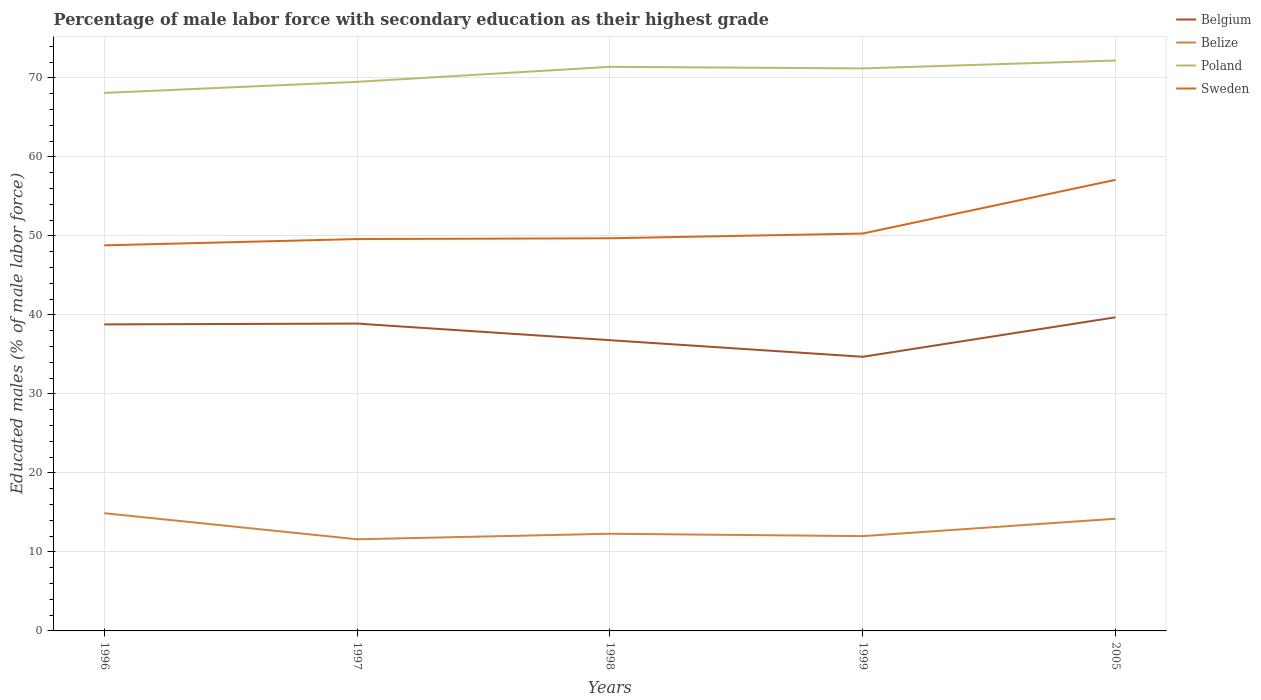How many different coloured lines are there?
Make the answer very short. 4. Across all years, what is the maximum percentage of male labor force with secondary education in Poland?
Provide a succinct answer. 68.1. What is the total percentage of male labor force with secondary education in Belize in the graph?
Your response must be concise. -0.4. What is the difference between the highest and the second highest percentage of male labor force with secondary education in Belize?
Offer a terse response. 3.3. How many lines are there?
Make the answer very short. 4. Does the graph contain any zero values?
Give a very brief answer. No. Does the graph contain grids?
Provide a succinct answer. Yes. Where does the legend appear in the graph?
Provide a succinct answer. Top right. How many legend labels are there?
Provide a short and direct response. 4. How are the legend labels stacked?
Your answer should be compact. Vertical. What is the title of the graph?
Offer a terse response. Percentage of male labor force with secondary education as their highest grade. What is the label or title of the X-axis?
Give a very brief answer. Years. What is the label or title of the Y-axis?
Ensure brevity in your answer.  Educated males (% of male labor force). What is the Educated males (% of male labor force) in Belgium in 1996?
Give a very brief answer. 38.8. What is the Educated males (% of male labor force) of Belize in 1996?
Offer a very short reply. 14.9. What is the Educated males (% of male labor force) in Poland in 1996?
Give a very brief answer. 68.1. What is the Educated males (% of male labor force) in Sweden in 1996?
Offer a very short reply. 48.8. What is the Educated males (% of male labor force) of Belgium in 1997?
Give a very brief answer. 38.9. What is the Educated males (% of male labor force) in Belize in 1997?
Ensure brevity in your answer.  11.6. What is the Educated males (% of male labor force) in Poland in 1997?
Your response must be concise. 69.5. What is the Educated males (% of male labor force) of Sweden in 1997?
Your response must be concise. 49.6. What is the Educated males (% of male labor force) in Belgium in 1998?
Keep it short and to the point. 36.8. What is the Educated males (% of male labor force) of Belize in 1998?
Give a very brief answer. 12.3. What is the Educated males (% of male labor force) in Poland in 1998?
Provide a succinct answer. 71.4. What is the Educated males (% of male labor force) of Sweden in 1998?
Offer a very short reply. 49.7. What is the Educated males (% of male labor force) of Belgium in 1999?
Your answer should be very brief. 34.7. What is the Educated males (% of male labor force) in Poland in 1999?
Your answer should be compact. 71.2. What is the Educated males (% of male labor force) of Sweden in 1999?
Make the answer very short. 50.3. What is the Educated males (% of male labor force) of Belgium in 2005?
Offer a very short reply. 39.7. What is the Educated males (% of male labor force) in Belize in 2005?
Provide a succinct answer. 14.2. What is the Educated males (% of male labor force) of Poland in 2005?
Give a very brief answer. 72.2. What is the Educated males (% of male labor force) of Sweden in 2005?
Offer a very short reply. 57.1. Across all years, what is the maximum Educated males (% of male labor force) of Belgium?
Make the answer very short. 39.7. Across all years, what is the maximum Educated males (% of male labor force) of Belize?
Provide a succinct answer. 14.9. Across all years, what is the maximum Educated males (% of male labor force) of Poland?
Offer a terse response. 72.2. Across all years, what is the maximum Educated males (% of male labor force) in Sweden?
Provide a succinct answer. 57.1. Across all years, what is the minimum Educated males (% of male labor force) in Belgium?
Keep it short and to the point. 34.7. Across all years, what is the minimum Educated males (% of male labor force) in Belize?
Provide a succinct answer. 11.6. Across all years, what is the minimum Educated males (% of male labor force) of Poland?
Your response must be concise. 68.1. Across all years, what is the minimum Educated males (% of male labor force) of Sweden?
Ensure brevity in your answer.  48.8. What is the total Educated males (% of male labor force) in Belgium in the graph?
Your response must be concise. 188.9. What is the total Educated males (% of male labor force) in Belize in the graph?
Ensure brevity in your answer.  65. What is the total Educated males (% of male labor force) of Poland in the graph?
Your answer should be compact. 352.4. What is the total Educated males (% of male labor force) in Sweden in the graph?
Offer a terse response. 255.5. What is the difference between the Educated males (% of male labor force) in Belize in 1996 and that in 1997?
Provide a succinct answer. 3.3. What is the difference between the Educated males (% of male labor force) of Poland in 1996 and that in 1997?
Make the answer very short. -1.4. What is the difference between the Educated males (% of male labor force) in Sweden in 1996 and that in 1997?
Keep it short and to the point. -0.8. What is the difference between the Educated males (% of male labor force) in Belize in 1996 and that in 1998?
Keep it short and to the point. 2.6. What is the difference between the Educated males (% of male labor force) of Poland in 1996 and that in 1998?
Provide a short and direct response. -3.3. What is the difference between the Educated males (% of male labor force) in Sweden in 1996 and that in 1998?
Your answer should be compact. -0.9. What is the difference between the Educated males (% of male labor force) of Sweden in 1996 and that in 1999?
Your answer should be very brief. -1.5. What is the difference between the Educated males (% of male labor force) in Belgium in 1996 and that in 2005?
Your answer should be compact. -0.9. What is the difference between the Educated males (% of male labor force) of Poland in 1996 and that in 2005?
Your answer should be compact. -4.1. What is the difference between the Educated males (% of male labor force) of Belgium in 1997 and that in 1998?
Provide a short and direct response. 2.1. What is the difference between the Educated males (% of male labor force) of Poland in 1997 and that in 1998?
Keep it short and to the point. -1.9. What is the difference between the Educated males (% of male labor force) of Poland in 1997 and that in 1999?
Your response must be concise. -1.7. What is the difference between the Educated males (% of male labor force) of Belize in 1997 and that in 2005?
Provide a succinct answer. -2.6. What is the difference between the Educated males (% of male labor force) in Sweden in 1997 and that in 2005?
Your answer should be very brief. -7.5. What is the difference between the Educated males (% of male labor force) of Belize in 1998 and that in 1999?
Your answer should be very brief. 0.3. What is the difference between the Educated males (% of male labor force) of Poland in 1998 and that in 1999?
Ensure brevity in your answer.  0.2. What is the difference between the Educated males (% of male labor force) in Sweden in 1998 and that in 1999?
Your answer should be compact. -0.6. What is the difference between the Educated males (% of male labor force) of Belgium in 1998 and that in 2005?
Provide a succinct answer. -2.9. What is the difference between the Educated males (% of male labor force) in Belize in 1998 and that in 2005?
Offer a very short reply. -1.9. What is the difference between the Educated males (% of male labor force) of Poland in 1998 and that in 2005?
Your response must be concise. -0.8. What is the difference between the Educated males (% of male labor force) in Sweden in 1998 and that in 2005?
Provide a short and direct response. -7.4. What is the difference between the Educated males (% of male labor force) of Belgium in 1999 and that in 2005?
Your answer should be compact. -5. What is the difference between the Educated males (% of male labor force) in Sweden in 1999 and that in 2005?
Provide a short and direct response. -6.8. What is the difference between the Educated males (% of male labor force) in Belgium in 1996 and the Educated males (% of male labor force) in Belize in 1997?
Give a very brief answer. 27.2. What is the difference between the Educated males (% of male labor force) in Belgium in 1996 and the Educated males (% of male labor force) in Poland in 1997?
Provide a short and direct response. -30.7. What is the difference between the Educated males (% of male labor force) of Belgium in 1996 and the Educated males (% of male labor force) of Sweden in 1997?
Provide a succinct answer. -10.8. What is the difference between the Educated males (% of male labor force) in Belize in 1996 and the Educated males (% of male labor force) in Poland in 1997?
Offer a terse response. -54.6. What is the difference between the Educated males (% of male labor force) in Belize in 1996 and the Educated males (% of male labor force) in Sweden in 1997?
Provide a succinct answer. -34.7. What is the difference between the Educated males (% of male labor force) in Poland in 1996 and the Educated males (% of male labor force) in Sweden in 1997?
Ensure brevity in your answer.  18.5. What is the difference between the Educated males (% of male labor force) of Belgium in 1996 and the Educated males (% of male labor force) of Poland in 1998?
Provide a succinct answer. -32.6. What is the difference between the Educated males (% of male labor force) in Belgium in 1996 and the Educated males (% of male labor force) in Sweden in 1998?
Ensure brevity in your answer.  -10.9. What is the difference between the Educated males (% of male labor force) of Belize in 1996 and the Educated males (% of male labor force) of Poland in 1998?
Your answer should be very brief. -56.5. What is the difference between the Educated males (% of male labor force) in Belize in 1996 and the Educated males (% of male labor force) in Sweden in 1998?
Keep it short and to the point. -34.8. What is the difference between the Educated males (% of male labor force) of Poland in 1996 and the Educated males (% of male labor force) of Sweden in 1998?
Keep it short and to the point. 18.4. What is the difference between the Educated males (% of male labor force) of Belgium in 1996 and the Educated males (% of male labor force) of Belize in 1999?
Give a very brief answer. 26.8. What is the difference between the Educated males (% of male labor force) in Belgium in 1996 and the Educated males (% of male labor force) in Poland in 1999?
Ensure brevity in your answer.  -32.4. What is the difference between the Educated males (% of male labor force) in Belize in 1996 and the Educated males (% of male labor force) in Poland in 1999?
Your answer should be compact. -56.3. What is the difference between the Educated males (% of male labor force) in Belize in 1996 and the Educated males (% of male labor force) in Sweden in 1999?
Your response must be concise. -35.4. What is the difference between the Educated males (% of male labor force) of Belgium in 1996 and the Educated males (% of male labor force) of Belize in 2005?
Keep it short and to the point. 24.6. What is the difference between the Educated males (% of male labor force) in Belgium in 1996 and the Educated males (% of male labor force) in Poland in 2005?
Provide a short and direct response. -33.4. What is the difference between the Educated males (% of male labor force) in Belgium in 1996 and the Educated males (% of male labor force) in Sweden in 2005?
Your answer should be compact. -18.3. What is the difference between the Educated males (% of male labor force) in Belize in 1996 and the Educated males (% of male labor force) in Poland in 2005?
Ensure brevity in your answer.  -57.3. What is the difference between the Educated males (% of male labor force) in Belize in 1996 and the Educated males (% of male labor force) in Sweden in 2005?
Offer a terse response. -42.2. What is the difference between the Educated males (% of male labor force) in Belgium in 1997 and the Educated males (% of male labor force) in Belize in 1998?
Offer a terse response. 26.6. What is the difference between the Educated males (% of male labor force) in Belgium in 1997 and the Educated males (% of male labor force) in Poland in 1998?
Your answer should be very brief. -32.5. What is the difference between the Educated males (% of male labor force) of Belgium in 1997 and the Educated males (% of male labor force) of Sweden in 1998?
Your answer should be very brief. -10.8. What is the difference between the Educated males (% of male labor force) in Belize in 1997 and the Educated males (% of male labor force) in Poland in 1998?
Your answer should be compact. -59.8. What is the difference between the Educated males (% of male labor force) of Belize in 1997 and the Educated males (% of male labor force) of Sweden in 1998?
Provide a succinct answer. -38.1. What is the difference between the Educated males (% of male labor force) of Poland in 1997 and the Educated males (% of male labor force) of Sweden in 1998?
Provide a succinct answer. 19.8. What is the difference between the Educated males (% of male labor force) in Belgium in 1997 and the Educated males (% of male labor force) in Belize in 1999?
Provide a succinct answer. 26.9. What is the difference between the Educated males (% of male labor force) in Belgium in 1997 and the Educated males (% of male labor force) in Poland in 1999?
Keep it short and to the point. -32.3. What is the difference between the Educated males (% of male labor force) of Belgium in 1997 and the Educated males (% of male labor force) of Sweden in 1999?
Your answer should be compact. -11.4. What is the difference between the Educated males (% of male labor force) of Belize in 1997 and the Educated males (% of male labor force) of Poland in 1999?
Give a very brief answer. -59.6. What is the difference between the Educated males (% of male labor force) in Belize in 1997 and the Educated males (% of male labor force) in Sweden in 1999?
Keep it short and to the point. -38.7. What is the difference between the Educated males (% of male labor force) in Poland in 1997 and the Educated males (% of male labor force) in Sweden in 1999?
Your response must be concise. 19.2. What is the difference between the Educated males (% of male labor force) in Belgium in 1997 and the Educated males (% of male labor force) in Belize in 2005?
Give a very brief answer. 24.7. What is the difference between the Educated males (% of male labor force) in Belgium in 1997 and the Educated males (% of male labor force) in Poland in 2005?
Offer a terse response. -33.3. What is the difference between the Educated males (% of male labor force) in Belgium in 1997 and the Educated males (% of male labor force) in Sweden in 2005?
Provide a succinct answer. -18.2. What is the difference between the Educated males (% of male labor force) in Belize in 1997 and the Educated males (% of male labor force) in Poland in 2005?
Provide a short and direct response. -60.6. What is the difference between the Educated males (% of male labor force) in Belize in 1997 and the Educated males (% of male labor force) in Sweden in 2005?
Give a very brief answer. -45.5. What is the difference between the Educated males (% of male labor force) in Belgium in 1998 and the Educated males (% of male labor force) in Belize in 1999?
Ensure brevity in your answer.  24.8. What is the difference between the Educated males (% of male labor force) in Belgium in 1998 and the Educated males (% of male labor force) in Poland in 1999?
Your answer should be very brief. -34.4. What is the difference between the Educated males (% of male labor force) in Belize in 1998 and the Educated males (% of male labor force) in Poland in 1999?
Your response must be concise. -58.9. What is the difference between the Educated males (% of male labor force) of Belize in 1998 and the Educated males (% of male labor force) of Sweden in 1999?
Offer a terse response. -38. What is the difference between the Educated males (% of male labor force) in Poland in 1998 and the Educated males (% of male labor force) in Sweden in 1999?
Offer a very short reply. 21.1. What is the difference between the Educated males (% of male labor force) of Belgium in 1998 and the Educated males (% of male labor force) of Belize in 2005?
Make the answer very short. 22.6. What is the difference between the Educated males (% of male labor force) of Belgium in 1998 and the Educated males (% of male labor force) of Poland in 2005?
Your response must be concise. -35.4. What is the difference between the Educated males (% of male labor force) of Belgium in 1998 and the Educated males (% of male labor force) of Sweden in 2005?
Your answer should be very brief. -20.3. What is the difference between the Educated males (% of male labor force) of Belize in 1998 and the Educated males (% of male labor force) of Poland in 2005?
Your response must be concise. -59.9. What is the difference between the Educated males (% of male labor force) in Belize in 1998 and the Educated males (% of male labor force) in Sweden in 2005?
Offer a very short reply. -44.8. What is the difference between the Educated males (% of male labor force) in Poland in 1998 and the Educated males (% of male labor force) in Sweden in 2005?
Ensure brevity in your answer.  14.3. What is the difference between the Educated males (% of male labor force) in Belgium in 1999 and the Educated males (% of male labor force) in Belize in 2005?
Offer a terse response. 20.5. What is the difference between the Educated males (% of male labor force) of Belgium in 1999 and the Educated males (% of male labor force) of Poland in 2005?
Offer a very short reply. -37.5. What is the difference between the Educated males (% of male labor force) in Belgium in 1999 and the Educated males (% of male labor force) in Sweden in 2005?
Keep it short and to the point. -22.4. What is the difference between the Educated males (% of male labor force) in Belize in 1999 and the Educated males (% of male labor force) in Poland in 2005?
Make the answer very short. -60.2. What is the difference between the Educated males (% of male labor force) in Belize in 1999 and the Educated males (% of male labor force) in Sweden in 2005?
Offer a terse response. -45.1. What is the difference between the Educated males (% of male labor force) in Poland in 1999 and the Educated males (% of male labor force) in Sweden in 2005?
Ensure brevity in your answer.  14.1. What is the average Educated males (% of male labor force) in Belgium per year?
Ensure brevity in your answer.  37.78. What is the average Educated males (% of male labor force) of Belize per year?
Offer a very short reply. 13. What is the average Educated males (% of male labor force) in Poland per year?
Offer a very short reply. 70.48. What is the average Educated males (% of male labor force) of Sweden per year?
Keep it short and to the point. 51.1. In the year 1996, what is the difference between the Educated males (% of male labor force) of Belgium and Educated males (% of male labor force) of Belize?
Your answer should be very brief. 23.9. In the year 1996, what is the difference between the Educated males (% of male labor force) of Belgium and Educated males (% of male labor force) of Poland?
Provide a succinct answer. -29.3. In the year 1996, what is the difference between the Educated males (% of male labor force) of Belize and Educated males (% of male labor force) of Poland?
Your answer should be very brief. -53.2. In the year 1996, what is the difference between the Educated males (% of male labor force) in Belize and Educated males (% of male labor force) in Sweden?
Offer a very short reply. -33.9. In the year 1996, what is the difference between the Educated males (% of male labor force) of Poland and Educated males (% of male labor force) of Sweden?
Offer a very short reply. 19.3. In the year 1997, what is the difference between the Educated males (% of male labor force) of Belgium and Educated males (% of male labor force) of Belize?
Provide a succinct answer. 27.3. In the year 1997, what is the difference between the Educated males (% of male labor force) of Belgium and Educated males (% of male labor force) of Poland?
Make the answer very short. -30.6. In the year 1997, what is the difference between the Educated males (% of male labor force) of Belgium and Educated males (% of male labor force) of Sweden?
Give a very brief answer. -10.7. In the year 1997, what is the difference between the Educated males (% of male labor force) in Belize and Educated males (% of male labor force) in Poland?
Give a very brief answer. -57.9. In the year 1997, what is the difference between the Educated males (% of male labor force) in Belize and Educated males (% of male labor force) in Sweden?
Ensure brevity in your answer.  -38. In the year 1997, what is the difference between the Educated males (% of male labor force) in Poland and Educated males (% of male labor force) in Sweden?
Provide a short and direct response. 19.9. In the year 1998, what is the difference between the Educated males (% of male labor force) of Belgium and Educated males (% of male labor force) of Poland?
Provide a short and direct response. -34.6. In the year 1998, what is the difference between the Educated males (% of male labor force) in Belize and Educated males (% of male labor force) in Poland?
Provide a succinct answer. -59.1. In the year 1998, what is the difference between the Educated males (% of male labor force) in Belize and Educated males (% of male labor force) in Sweden?
Your response must be concise. -37.4. In the year 1998, what is the difference between the Educated males (% of male labor force) in Poland and Educated males (% of male labor force) in Sweden?
Keep it short and to the point. 21.7. In the year 1999, what is the difference between the Educated males (% of male labor force) in Belgium and Educated males (% of male labor force) in Belize?
Provide a short and direct response. 22.7. In the year 1999, what is the difference between the Educated males (% of male labor force) in Belgium and Educated males (% of male labor force) in Poland?
Provide a succinct answer. -36.5. In the year 1999, what is the difference between the Educated males (% of male labor force) in Belgium and Educated males (% of male labor force) in Sweden?
Offer a very short reply. -15.6. In the year 1999, what is the difference between the Educated males (% of male labor force) in Belize and Educated males (% of male labor force) in Poland?
Ensure brevity in your answer.  -59.2. In the year 1999, what is the difference between the Educated males (% of male labor force) in Belize and Educated males (% of male labor force) in Sweden?
Your answer should be very brief. -38.3. In the year 1999, what is the difference between the Educated males (% of male labor force) of Poland and Educated males (% of male labor force) of Sweden?
Offer a terse response. 20.9. In the year 2005, what is the difference between the Educated males (% of male labor force) in Belgium and Educated males (% of male labor force) in Belize?
Your answer should be very brief. 25.5. In the year 2005, what is the difference between the Educated males (% of male labor force) in Belgium and Educated males (% of male labor force) in Poland?
Your answer should be compact. -32.5. In the year 2005, what is the difference between the Educated males (% of male labor force) in Belgium and Educated males (% of male labor force) in Sweden?
Your response must be concise. -17.4. In the year 2005, what is the difference between the Educated males (% of male labor force) of Belize and Educated males (% of male labor force) of Poland?
Provide a short and direct response. -58. In the year 2005, what is the difference between the Educated males (% of male labor force) of Belize and Educated males (% of male labor force) of Sweden?
Your answer should be very brief. -42.9. What is the ratio of the Educated males (% of male labor force) in Belgium in 1996 to that in 1997?
Your answer should be compact. 1. What is the ratio of the Educated males (% of male labor force) in Belize in 1996 to that in 1997?
Offer a terse response. 1.28. What is the ratio of the Educated males (% of male labor force) of Poland in 1996 to that in 1997?
Make the answer very short. 0.98. What is the ratio of the Educated males (% of male labor force) in Sweden in 1996 to that in 1997?
Ensure brevity in your answer.  0.98. What is the ratio of the Educated males (% of male labor force) of Belgium in 1996 to that in 1998?
Your response must be concise. 1.05. What is the ratio of the Educated males (% of male labor force) of Belize in 1996 to that in 1998?
Ensure brevity in your answer.  1.21. What is the ratio of the Educated males (% of male labor force) of Poland in 1996 to that in 1998?
Make the answer very short. 0.95. What is the ratio of the Educated males (% of male labor force) in Sweden in 1996 to that in 1998?
Offer a very short reply. 0.98. What is the ratio of the Educated males (% of male labor force) in Belgium in 1996 to that in 1999?
Your response must be concise. 1.12. What is the ratio of the Educated males (% of male labor force) of Belize in 1996 to that in 1999?
Your response must be concise. 1.24. What is the ratio of the Educated males (% of male labor force) of Poland in 1996 to that in 1999?
Offer a very short reply. 0.96. What is the ratio of the Educated males (% of male labor force) in Sweden in 1996 to that in 1999?
Offer a terse response. 0.97. What is the ratio of the Educated males (% of male labor force) of Belgium in 1996 to that in 2005?
Make the answer very short. 0.98. What is the ratio of the Educated males (% of male labor force) in Belize in 1996 to that in 2005?
Provide a short and direct response. 1.05. What is the ratio of the Educated males (% of male labor force) in Poland in 1996 to that in 2005?
Offer a very short reply. 0.94. What is the ratio of the Educated males (% of male labor force) in Sweden in 1996 to that in 2005?
Keep it short and to the point. 0.85. What is the ratio of the Educated males (% of male labor force) of Belgium in 1997 to that in 1998?
Your answer should be very brief. 1.06. What is the ratio of the Educated males (% of male labor force) in Belize in 1997 to that in 1998?
Your response must be concise. 0.94. What is the ratio of the Educated males (% of male labor force) in Poland in 1997 to that in 1998?
Ensure brevity in your answer.  0.97. What is the ratio of the Educated males (% of male labor force) in Belgium in 1997 to that in 1999?
Give a very brief answer. 1.12. What is the ratio of the Educated males (% of male labor force) of Belize in 1997 to that in 1999?
Offer a very short reply. 0.97. What is the ratio of the Educated males (% of male labor force) in Poland in 1997 to that in 1999?
Offer a very short reply. 0.98. What is the ratio of the Educated males (% of male labor force) in Sweden in 1997 to that in 1999?
Your answer should be compact. 0.99. What is the ratio of the Educated males (% of male labor force) in Belgium in 1997 to that in 2005?
Offer a terse response. 0.98. What is the ratio of the Educated males (% of male labor force) in Belize in 1997 to that in 2005?
Provide a succinct answer. 0.82. What is the ratio of the Educated males (% of male labor force) of Poland in 1997 to that in 2005?
Provide a short and direct response. 0.96. What is the ratio of the Educated males (% of male labor force) of Sweden in 1997 to that in 2005?
Give a very brief answer. 0.87. What is the ratio of the Educated males (% of male labor force) of Belgium in 1998 to that in 1999?
Ensure brevity in your answer.  1.06. What is the ratio of the Educated males (% of male labor force) of Belize in 1998 to that in 1999?
Make the answer very short. 1.02. What is the ratio of the Educated males (% of male labor force) in Belgium in 1998 to that in 2005?
Offer a terse response. 0.93. What is the ratio of the Educated males (% of male labor force) of Belize in 1998 to that in 2005?
Your answer should be compact. 0.87. What is the ratio of the Educated males (% of male labor force) in Poland in 1998 to that in 2005?
Offer a terse response. 0.99. What is the ratio of the Educated males (% of male labor force) in Sweden in 1998 to that in 2005?
Keep it short and to the point. 0.87. What is the ratio of the Educated males (% of male labor force) of Belgium in 1999 to that in 2005?
Provide a succinct answer. 0.87. What is the ratio of the Educated males (% of male labor force) of Belize in 1999 to that in 2005?
Ensure brevity in your answer.  0.85. What is the ratio of the Educated males (% of male labor force) of Poland in 1999 to that in 2005?
Your answer should be very brief. 0.99. What is the ratio of the Educated males (% of male labor force) in Sweden in 1999 to that in 2005?
Offer a very short reply. 0.88. What is the difference between the highest and the second highest Educated males (% of male labor force) of Belize?
Keep it short and to the point. 0.7. What is the difference between the highest and the second highest Educated males (% of male labor force) in Poland?
Your answer should be compact. 0.8. What is the difference between the highest and the second highest Educated males (% of male labor force) of Sweden?
Your response must be concise. 6.8. What is the difference between the highest and the lowest Educated males (% of male labor force) of Belgium?
Ensure brevity in your answer.  5. What is the difference between the highest and the lowest Educated males (% of male labor force) of Poland?
Your answer should be very brief. 4.1. What is the difference between the highest and the lowest Educated males (% of male labor force) in Sweden?
Provide a succinct answer. 8.3. 